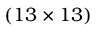Convert formula to latex. <formula><loc_0><loc_0><loc_500><loc_500>( 1 3 \times 1 3 )</formula> 